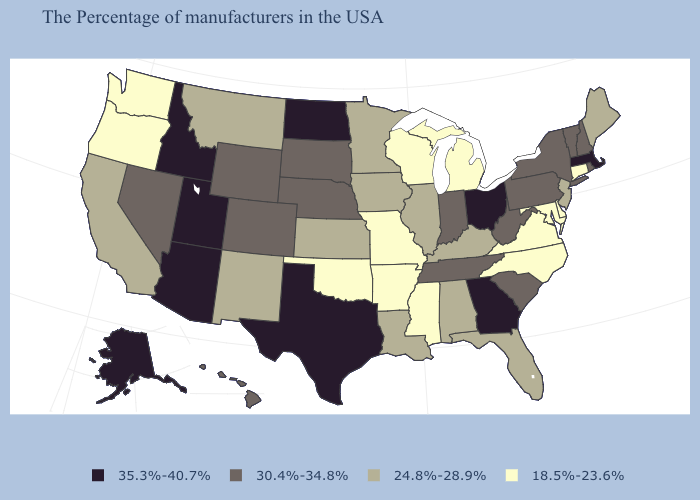Name the states that have a value in the range 30.4%-34.8%?
Be succinct. Rhode Island, New Hampshire, Vermont, New York, Pennsylvania, South Carolina, West Virginia, Indiana, Tennessee, Nebraska, South Dakota, Wyoming, Colorado, Nevada, Hawaii. Among the states that border Washington , does Oregon have the lowest value?
Write a very short answer. Yes. Does Georgia have the highest value in the USA?
Be succinct. Yes. What is the highest value in the South ?
Quick response, please. 35.3%-40.7%. What is the value of Illinois?
Write a very short answer. 24.8%-28.9%. Name the states that have a value in the range 35.3%-40.7%?
Write a very short answer. Massachusetts, Ohio, Georgia, Texas, North Dakota, Utah, Arizona, Idaho, Alaska. Among the states that border New Hampshire , does Massachusetts have the highest value?
Short answer required. Yes. What is the lowest value in the USA?
Short answer required. 18.5%-23.6%. Does Arizona have the highest value in the USA?
Quick response, please. Yes. Does the first symbol in the legend represent the smallest category?
Concise answer only. No. Name the states that have a value in the range 30.4%-34.8%?
Concise answer only. Rhode Island, New Hampshire, Vermont, New York, Pennsylvania, South Carolina, West Virginia, Indiana, Tennessee, Nebraska, South Dakota, Wyoming, Colorado, Nevada, Hawaii. Does Ohio have the lowest value in the USA?
Answer briefly. No. Does the map have missing data?
Short answer required. No. Which states hav the highest value in the Northeast?
Be succinct. Massachusetts. What is the value of Tennessee?
Quick response, please. 30.4%-34.8%. 